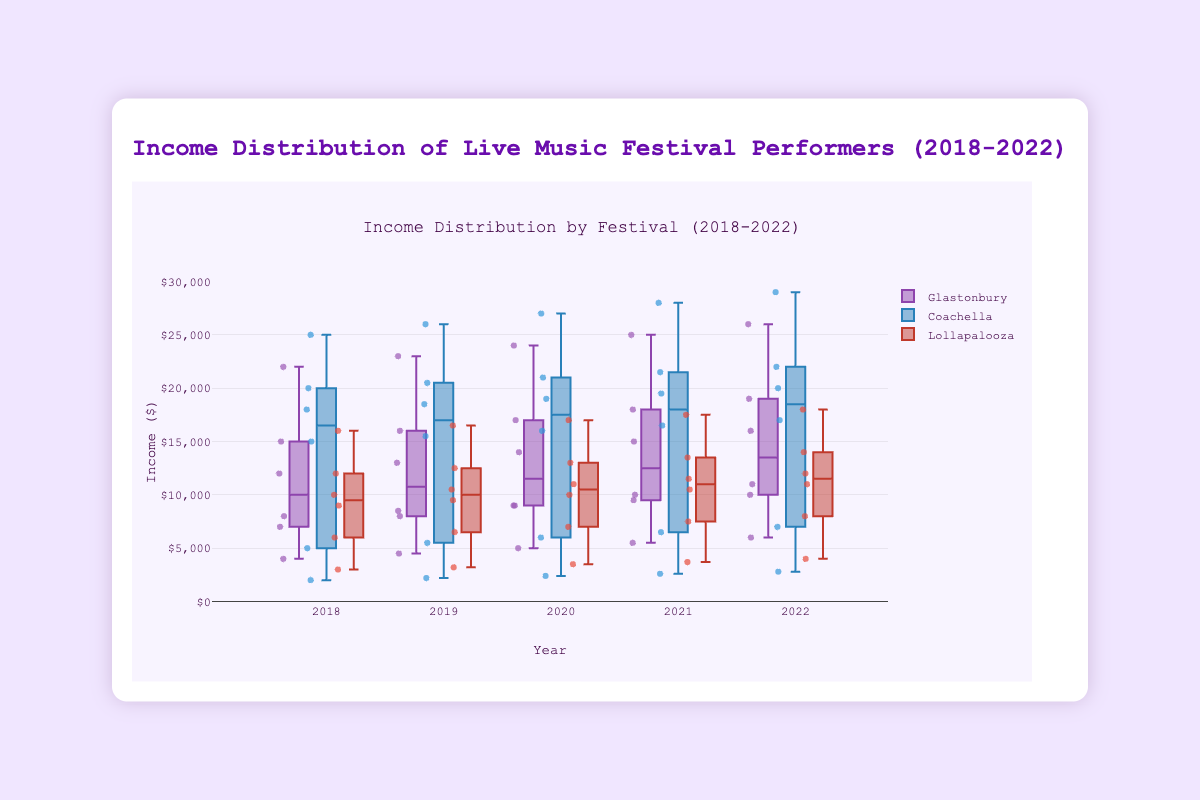What is the title of the box plot? The title of the box plot is located at the top center of the plot.
Answer: Income Distribution of Live Music Festival Performers (2018-2022) Which festival had the narrowest interquartile range (IQR) in 2018? The IQR is the range between the first and third quartiles. By examining the box heights in 2018, we see Lollapalooza has the narrowest box, implying the smallest IQR.
Answer: Lollapalooza In which year did Glastonbury performers have the highest median income? The median income is the line inside the box. In 2022, the line inside Glastonbury's box is at the highest position compared to other years.
Answer: 2022 Compare the median income of performers at Coachella and Lollapalooza in 2020. Which is higher? The median is the line inside the box. For 2020, Coachella's median line is higher than that of Lollapalooza.
Answer: Coachella Which year shows the largest range of incomes for Glastonbury performers? The range is the distance between the lowest and highest points in the whiskers. In 2022, Glastonbury has the largest distance between the whiskers.
Answer: 2022 What is the median income for Lollapalooza performers in 2019? The median is the horizontal line within the box for Lollapalooza in 2019.
Answer: 10500 How does the income distribution for Coachella in 2018 compare with 2022 in terms of spread? To compare spreads, observe the whisker lengths and box sizes. In 2022, Coachella's box is taller and whiskers are farther apart compared to 2018, indicating a larger spread.
Answer: 2022 has a larger spread Which festival in 2022 had the lowest minimum income? The minimum income is the bottom point of the whiskers. For 2022, Coachella has the lowest whisker.
Answer: Coachella How did the median income for Glastonbury performers change from 2020 to 2021? Compare the median line (inside the box) positions from 2020 to 2021 for Glastonbury. The median line increased in 2021.
Answer: Increased In which year did Lollapalooza performers have the smallest interquartile range (IQR)? Examine Lollapalooza's box heights. In 2018, Lollapalooza has the shortest box, indicating the smallest IQR.
Answer: 2018 